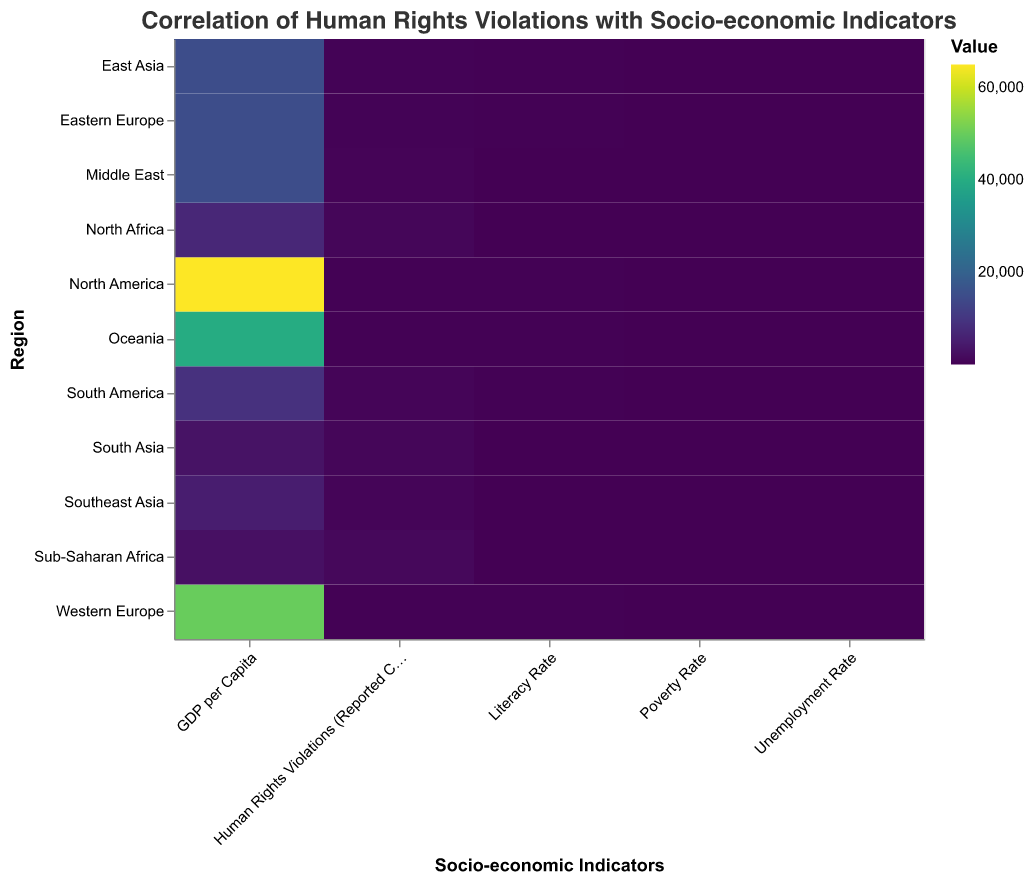What's the region with the highest number of reported Human Rights Violations (Reported Cases)? Look at the column for "Human Rights Violations (Reported Cases)" and identify the region with the largest value. Sub-Saharan Africa has the highest number of reported cases with a value of 1200.
Answer: Sub-Saharan Africa Which region has the highest GDP per Capita? Look at the column for "GDP per Capita" and identify the region with the largest value. North America has the highest GDP per Capita with a value of 65000.
Answer: North America Which region has the lowest Literacy Rate? Look at the column for "Literacy Rate" and identify the region with the smallest value. Sub-Saharan Africa has the lowest Literacy Rate with a value of 70.
Answer: Sub-Saharan Africa How does North America's Human Rights Violations (Reported Cases) compare to Western Europe? Compare the values in the "Human Rights Violations (Reported Cases)" column for North America and Western Europe. North America has 150 reported cases, while Western Europe has 100.
Answer: North America has more reported cases What is the average GDP per Capita across all listed regions? Sum the GDP per Capita values for all regions and divide by the number of regions. (65000 + 9000 + 50000 + 15000 + 2500 + 7000 + 15000 + 3000 + 15000 + 5000 + 40000) / 11 = 196,500 / 11 ≈ 17,864.
Answer: 17,864 Which region has the highest Unemployment Rate, and what is that rate? Look at the column for "Unemployment Rate" and identify the region with the largest value. Sub-Saharan Africa has the highest Unemployment Rate with a value of 15%.
Answer: Sub-Saharan Africa, 15% Compare the Poverty Rate of North Africa and South Asia. Which has a higher rate? Compare the values in the "Poverty Rate" column for North Africa and South Asia. North Africa has a rate of 40%, while South Asia has a rate of 35%.
Answer: North Africa What is the correlation between GDP per Capita and Human Rights Violations (Reported Cases) based on visual inspection? By observing the split between high GDP per Capita regions (e.g., North America, Western Europe) and lower GDP per Capita regions (e.g., Sub-Saharan Africa, South Asia) in correlation with their Human Rights Violations, regions with lower GDP per Capita tend to have higher reported cases.
Answer: Negative correlation Which region has the smallest difference between its Literacy Rate and Unemployment Rate? Calculate the difference between Literacy Rate and Unemployment Rate for each region and identify the smallest difference. For example, North America: 99-5=94, South America: 92-12=80, etc. Oceania has the smallest difference with 97-6=91.
Answer: Oceania Compare the reported Human Rights Violations of East Asia and Southeast Asia. Which region reports more cases? Compare the values in the "Human Rights Violations (Reported Cases)" column for East Asia and Southeast Asia. East Asia reports 300 cases, while Southeast Asia reports 700 cases.
Answer: Southeast Asia 